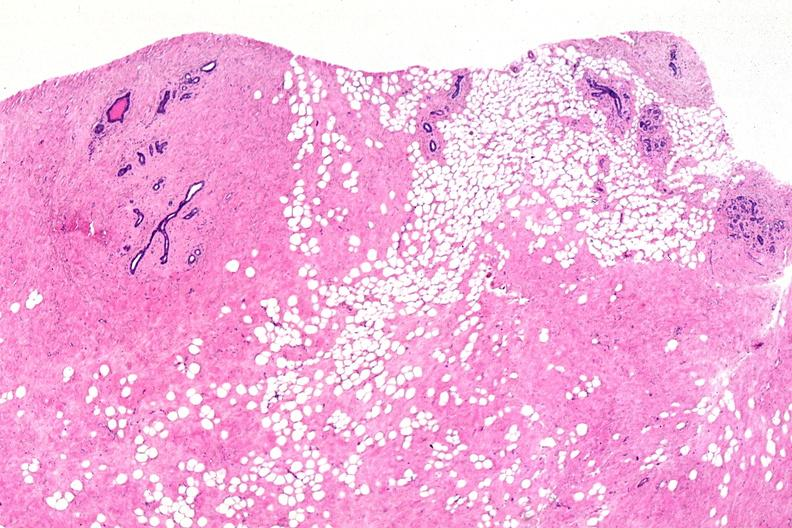does female reproductive show normal breast?
Answer the question using a single word or phrase. No 